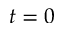<formula> <loc_0><loc_0><loc_500><loc_500>t = 0</formula> 